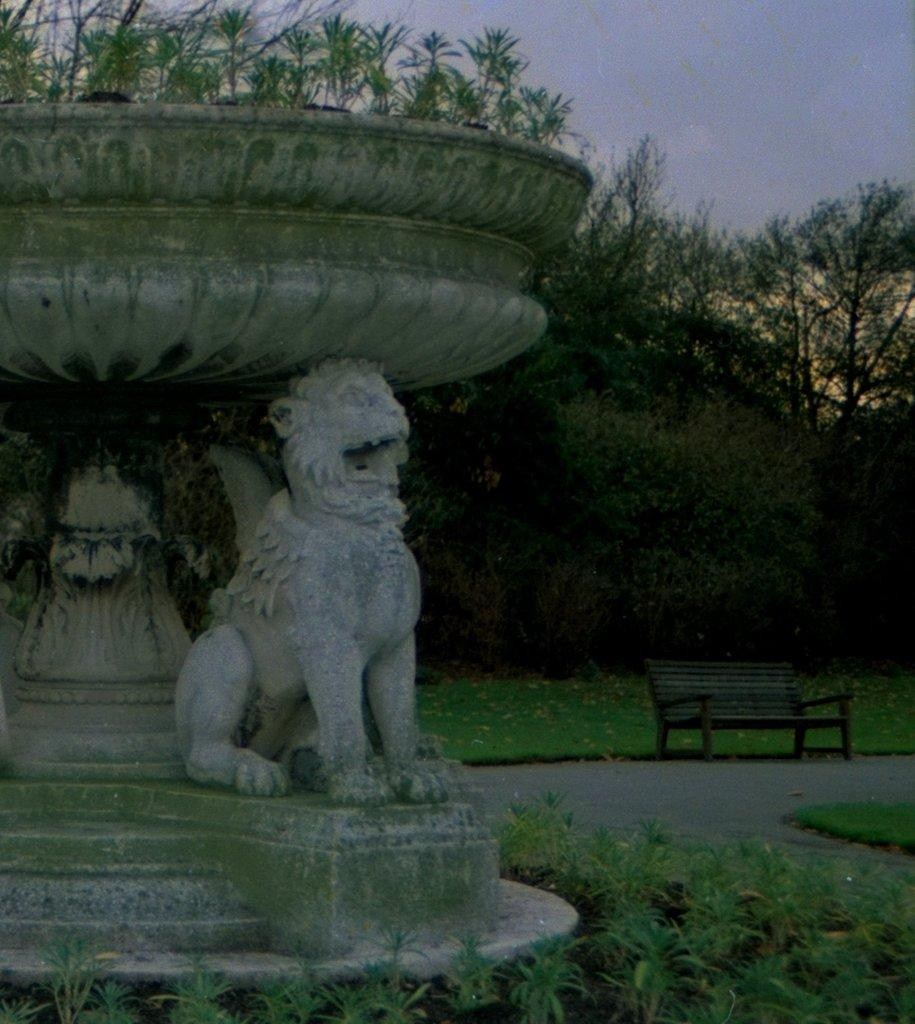What type of sculpture can be seen in the picture? There is a sculpture of a lion in the picture. What type of seating is available in the park? There is a bench in the park. What can be seen in the background of the picture? There are trees and the sky visible in the background of the picture. What type of jewel is hanging from the lion's neck in the picture? There is no jewel hanging from the lion's neck in the picture; it is a sculpture and not a real lion. 